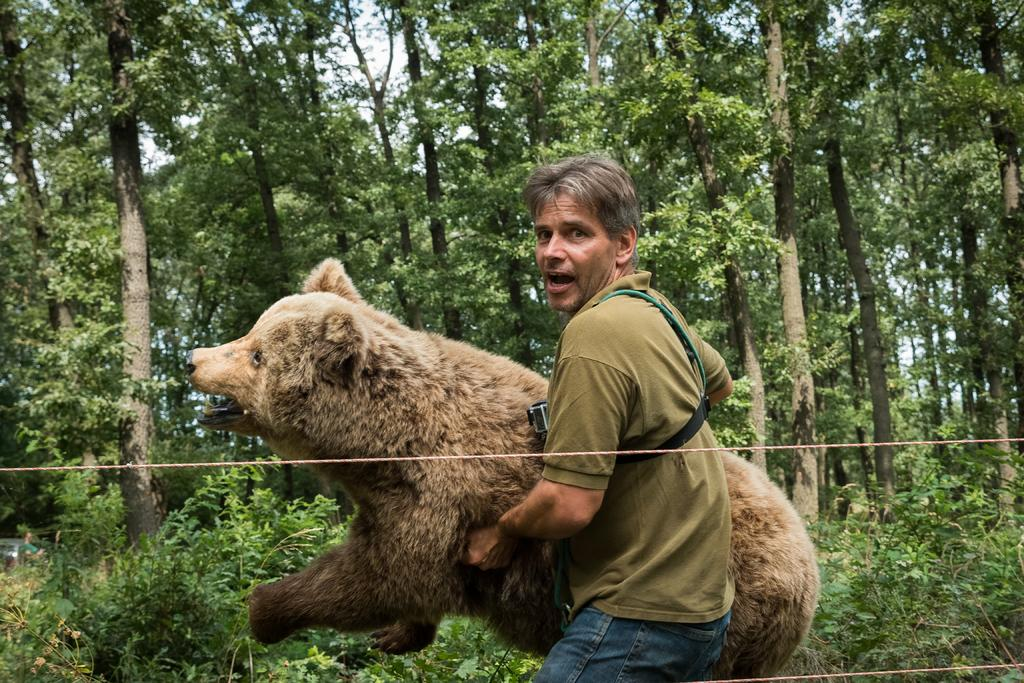What is the man in the image wearing? The man is wearing a green t-shirt and blue jeans. What is the man holding in his hands? The man is holding a bear in his hands. What can be seen in the background of the image? There are many trees and plants in the background of the image. What type of music is the band playing in the background of the image? There is no band present in the image, so it is not possible to determine what type of music they might be playing. 